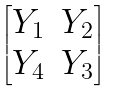<formula> <loc_0><loc_0><loc_500><loc_500>\begin{bmatrix} Y _ { 1 } & Y _ { 2 } \\ Y _ { 4 } & Y _ { 3 } \end{bmatrix}</formula> 